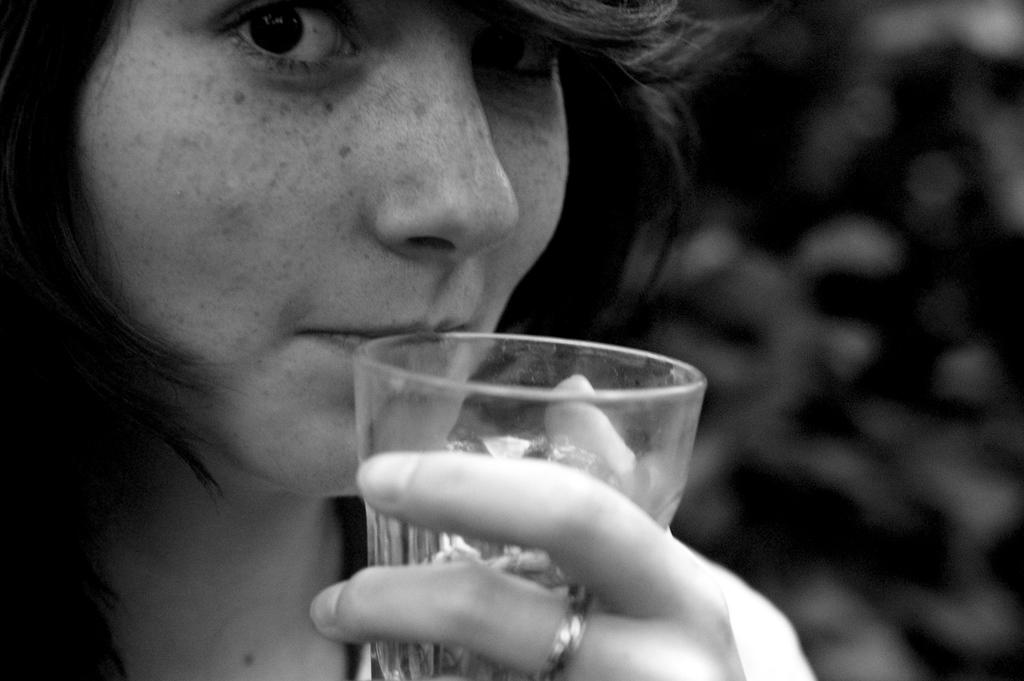What is the color scheme of the image? The image is black and white. Who is present in the image? There is a woman in the image. What is the woman holding in the image? The woman is holding a glass. How is the woman interacting with the glass? The glass is nearer to her lips. Can you describe the background of the image? The background of the image is unclear. What type of vest is the goat wearing in the image? There is no goat or vest present in the image. How much butter is visible on the woman's plate in the image? There is no butter visible in the image; only a woman holding a glass is present. 